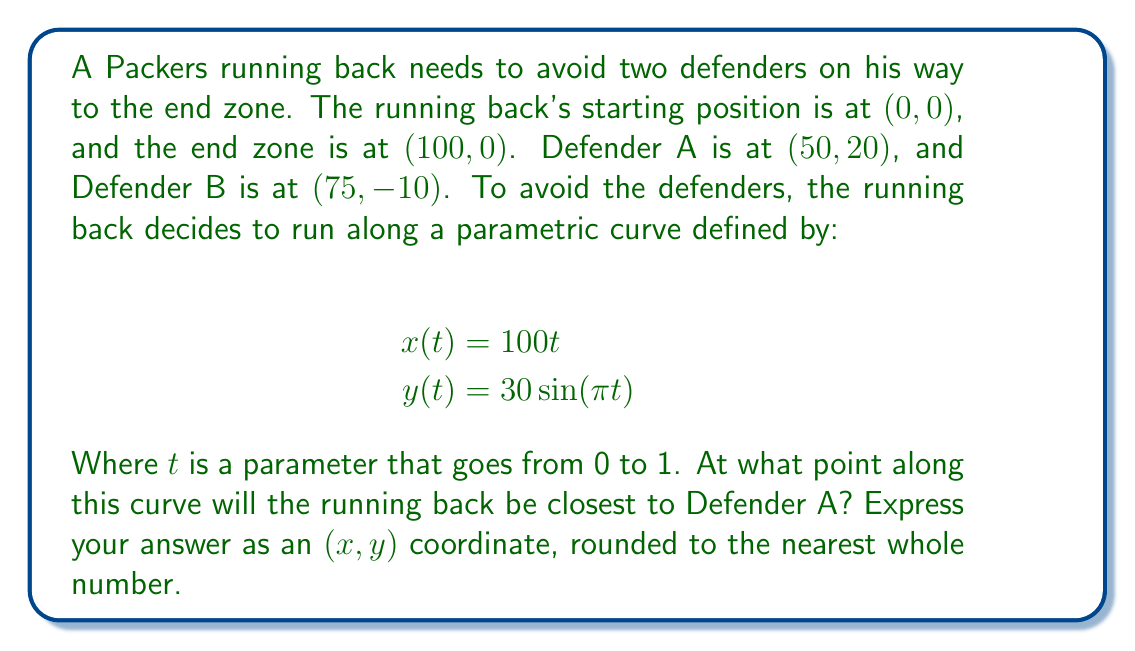Can you answer this question? To solve this problem, we need to find the point on the parametric curve that minimizes the distance to Defender A. We can do this by following these steps:

1) The distance between a point (x, y) on the curve and Defender A (50, 20) is given by:

   $$d(t) = \sqrt{(x(t) - 50)^2 + (y(t) - 20)^2}$$

2) Substituting our parametric equations:

   $$d(t) = \sqrt{(100t - 50)^2 + (30\sin(\pi t) - 20)^2}$$

3) To find the minimum distance, we need to find where the derivative of this function equals zero. However, this leads to a complex equation that's difficult to solve analytically.

4) Instead, we can use a numerical approach. We'll evaluate the distance at small intervals of t and find the minimum.

5) Let's create a table of values (showing only a few for brevity):

   t   | x    | y       | Distance to A
   0.0 | 0    | 0       | 53.85
   0.1 | 10   | 18.54   | 41.23
   0.2 | 20   | 29.39   | 32.43
   0.3 | 30   | 29.39   | 24.70
   0.4 | 40   | 18.54   | 18.21
   0.5 | 50   | 0       | 20.00
   0.6 | 60   | -18.54  | 28.21
   ... | ...  | ...     | ...

6) The minimum distance occurs when t is approximately 0.41.

7) At t = 0.41:
   x = 100 * 0.41 = 41
   y = 30 * sin(π * 0.41) ≈ 22

8) Therefore, the point closest to Defender A is approximately (41, 22).
Answer: (41, 22) 